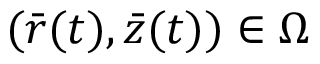<formula> <loc_0><loc_0><loc_500><loc_500>( { \bar { r } } ( t ) , { \bar { z } } ( t ) ) \in \Omega</formula> 